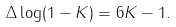<formula> <loc_0><loc_0><loc_500><loc_500>\Delta \log ( 1 - K ) = 6 K - 1 .</formula> 